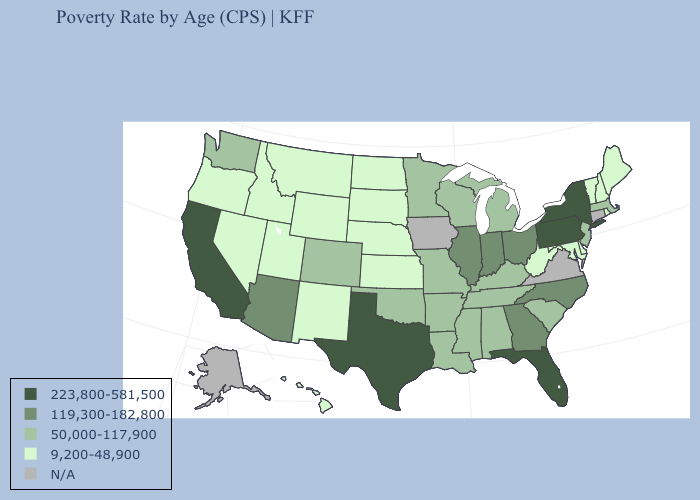Name the states that have a value in the range 50,000-117,900?
Keep it brief. Alabama, Arkansas, Colorado, Kentucky, Louisiana, Massachusetts, Michigan, Minnesota, Mississippi, Missouri, New Jersey, Oklahoma, South Carolina, Tennessee, Washington, Wisconsin. Does North Dakota have the lowest value in the USA?
Quick response, please. Yes. Name the states that have a value in the range 223,800-581,500?
Be succinct. California, Florida, New York, Pennsylvania, Texas. Does Missouri have the lowest value in the USA?
Quick response, please. No. What is the lowest value in the USA?
Answer briefly. 9,200-48,900. What is the highest value in the USA?
Answer briefly. 223,800-581,500. Among the states that border North Dakota , which have the highest value?
Be succinct. Minnesota. Does Maryland have the lowest value in the South?
Quick response, please. Yes. What is the lowest value in the USA?
Keep it brief. 9,200-48,900. Name the states that have a value in the range 50,000-117,900?
Be succinct. Alabama, Arkansas, Colorado, Kentucky, Louisiana, Massachusetts, Michigan, Minnesota, Mississippi, Missouri, New Jersey, Oklahoma, South Carolina, Tennessee, Washington, Wisconsin. Is the legend a continuous bar?
Concise answer only. No. What is the highest value in states that border New Hampshire?
Be succinct. 50,000-117,900. What is the value of New Mexico?
Quick response, please. 9,200-48,900. 